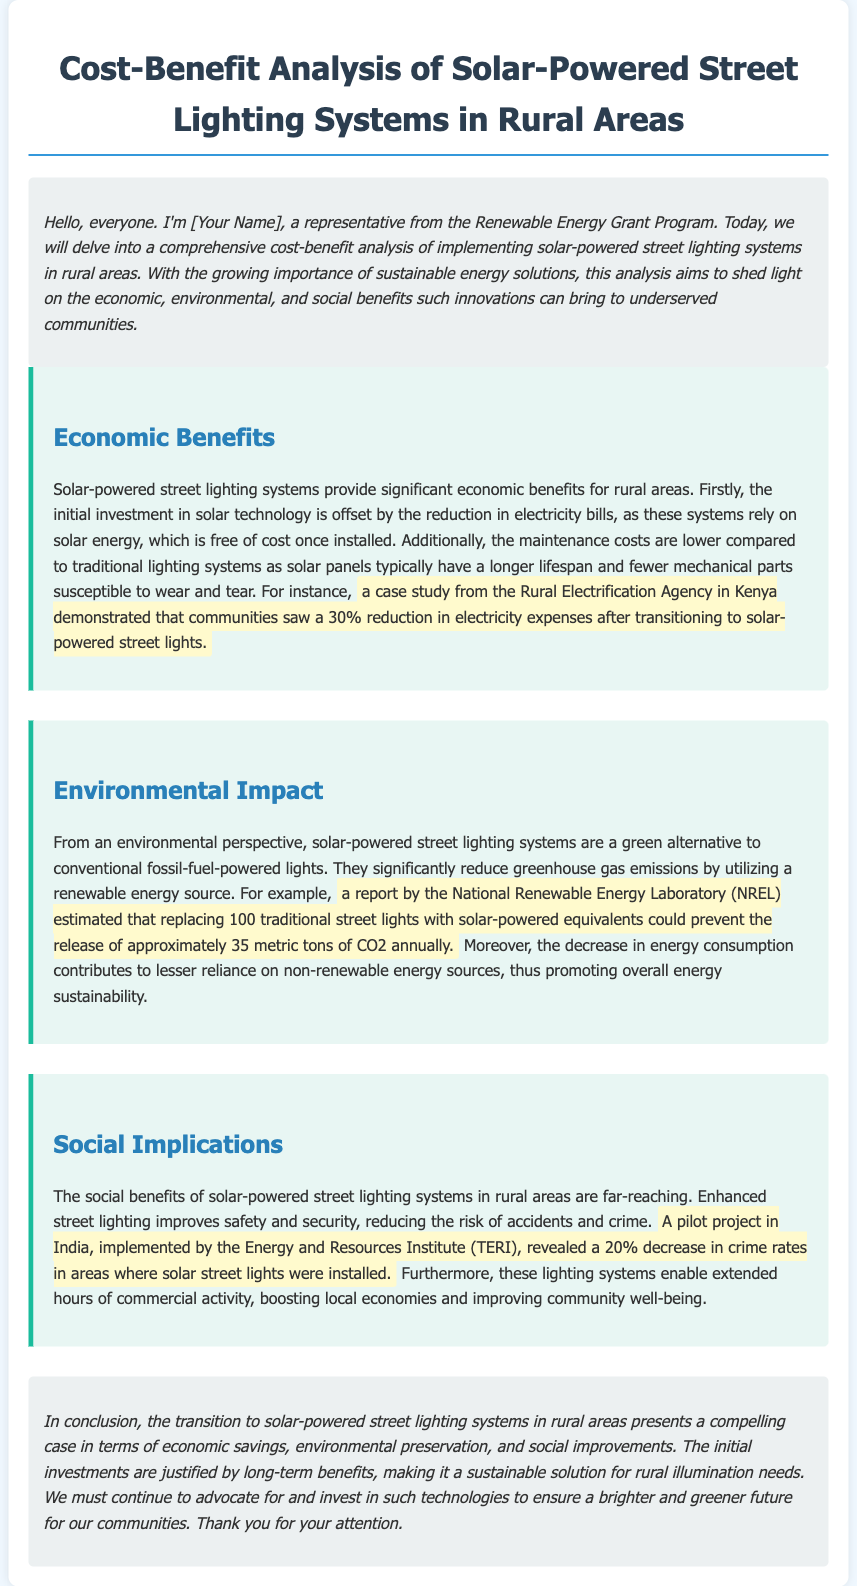What is the primary focus of the cost-benefit analysis? The document primarily focuses on the economic, environmental, and social benefits of implementing solar-powered street lighting systems in rural areas.
Answer: solar-powered street lighting systems What was the percentage reduction in electricity expenses mentioned in the case study from Kenya? The case study highlighted a 30% reduction in electricity expenses after transitioning to solar-powered street lights.
Answer: 30% What greenhouse gas emission reduction is estimated by replacing 100 traditional street lights? The report by NREL estimated that replacing 100 traditional street lights could prevent the release of approximately 35 metric tons of CO2 annually.
Answer: 35 metric tons What was the percentage decrease in crime rates in the TERI pilot project in India? The pilot project revealed a 20% decrease in crime rates in areas where solar street lights were installed.
Answer: 20% What does the conclusion emphasize regarding the investments in solar-powered street lighting systems? The conclusion emphasizes that the initial investments are justified by long-term benefits, making it a sustainable solution.
Answer: long-term benefits 